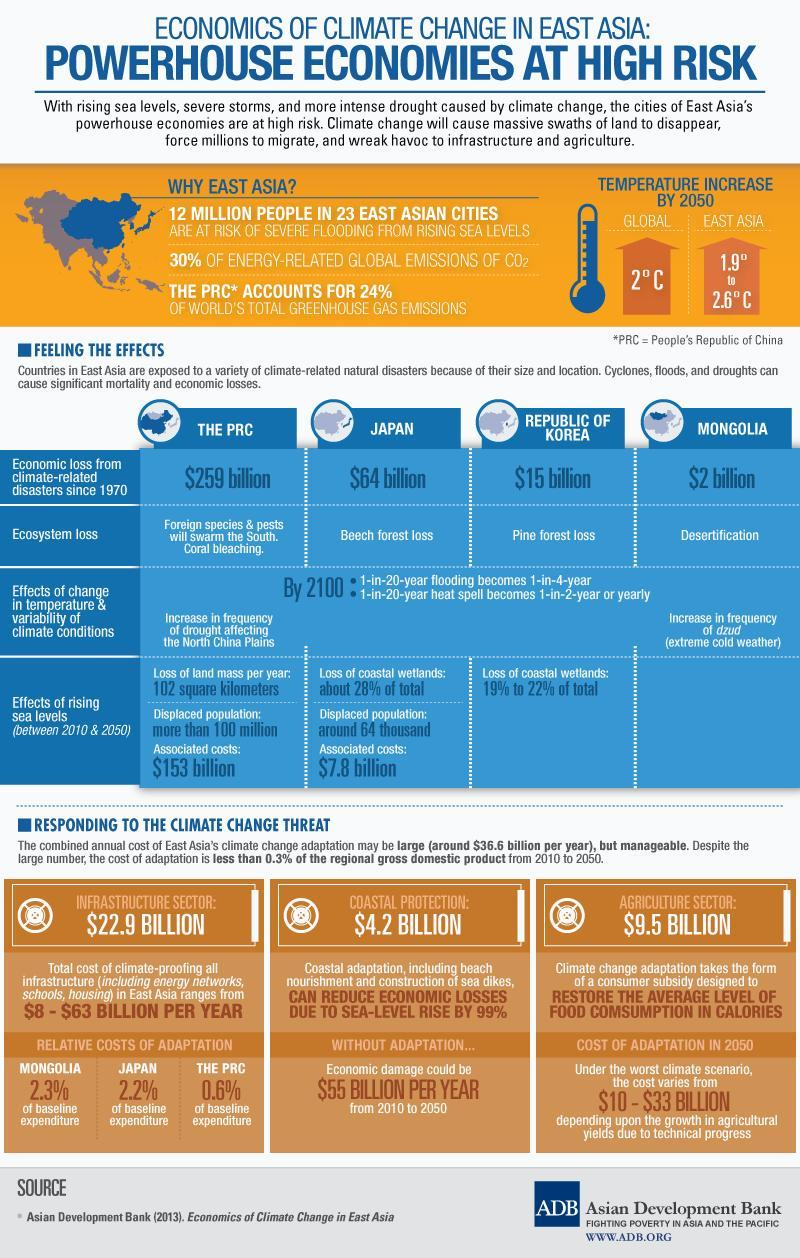What is the expected high temperature rise in East Asia by 2050 in degree Celsius??
Answer the question with a short phrase. 2.6 How much it costs to Japan due to the rising sea level? $7.8 billion How much it cost to East Asia to regain its Agriculture from climate change issues? $9.5 billion How many people in japan have been relocated due to rising sea level issues? around 64 thousand What amount of wetlands have been lost by the Republic of Korea due to the rise of sea level? 19% to 22% of total What will be the global rate of heat energy emission by 2050 in degree Celsius? 2 What percentage of total greenhouse gas emissions is not due to PRC? 76 Which country had the second least economic crisis among other countries listed in the infographic? Japan How much it cost to East Asia to protect coastal region from climate change issues? $4.2 Billion How much is the relative costs of adaptation of PRC? 0.6% 